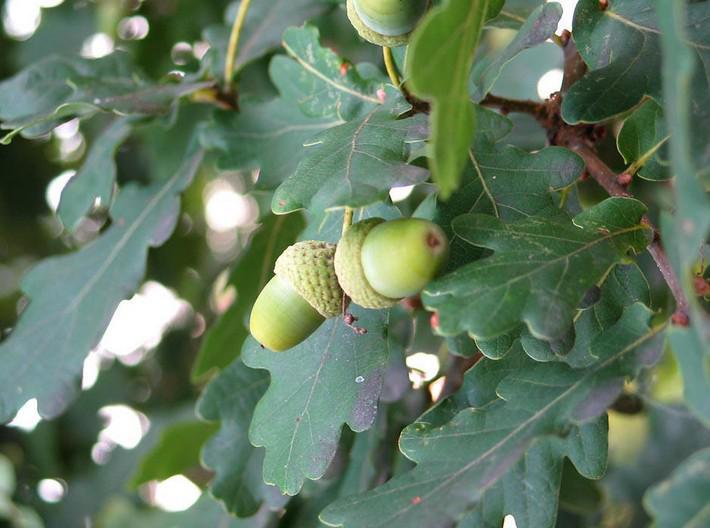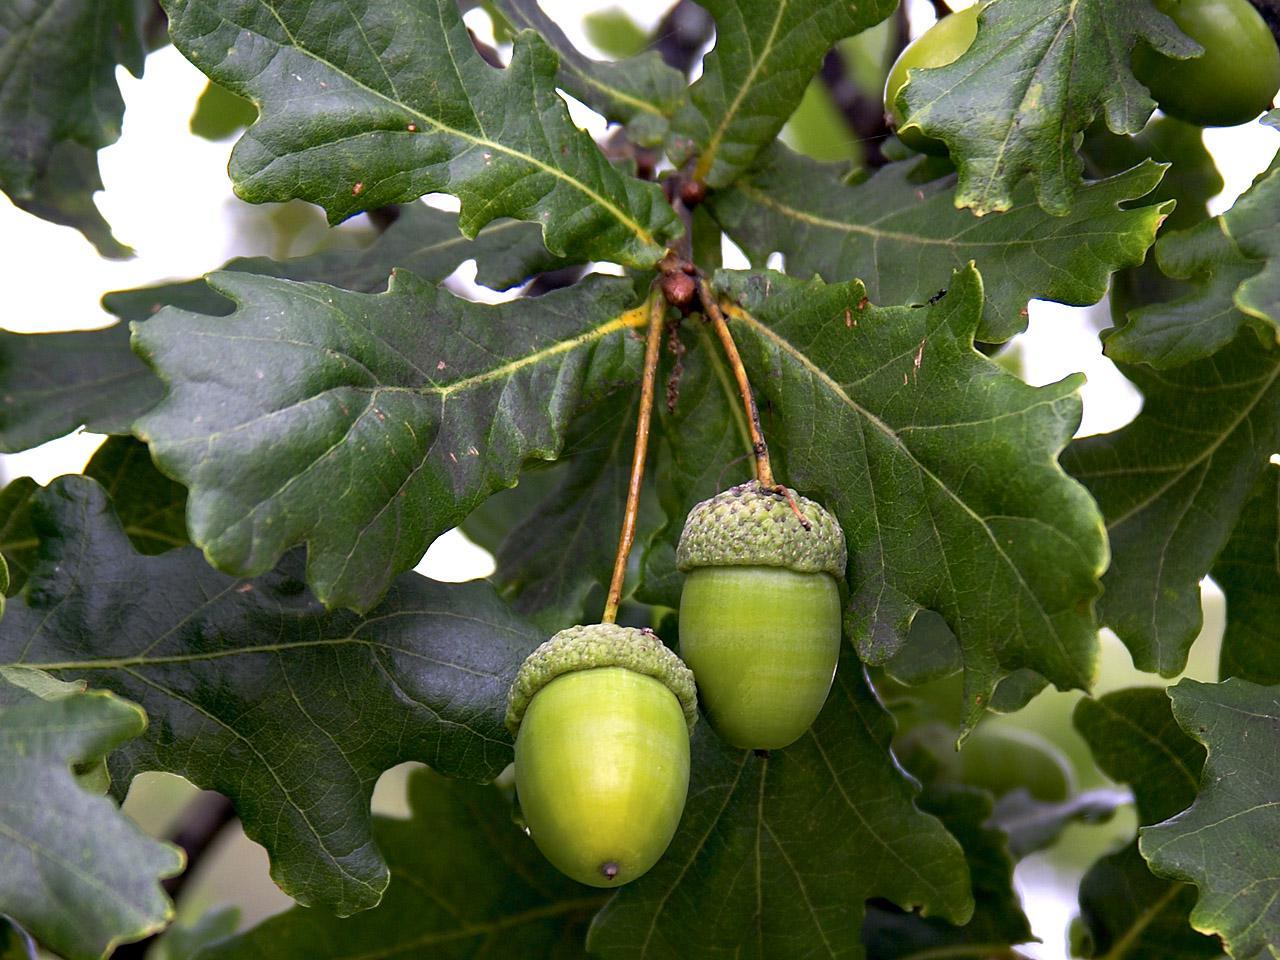The first image is the image on the left, the second image is the image on the right. Considering the images on both sides, is "One image shows a single acorn attached to an oak tree." valid? Answer yes or no. No. The first image is the image on the left, the second image is the image on the right. Given the left and right images, does the statement "The left image contains only acorns that are green, and the right image contains only acorns that are brown." hold true? Answer yes or no. No. 